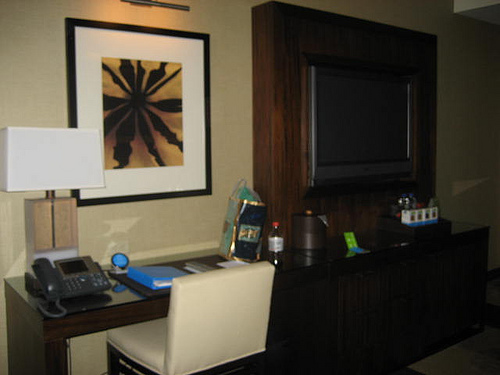<image>What color is the mantle? It is ambiguous. The mantle can be brown or there may be no mantle in the image. What is the appliance on the counter? I am not sure what the appliance on the counter is. It could be a coffee maker or a phone. What color is the mantle? The color of the mantle is brown. What is the appliance on the counter? I don't know what the appliance on the counter is. It can be seen as a coffee maker, phone, or telephone. 